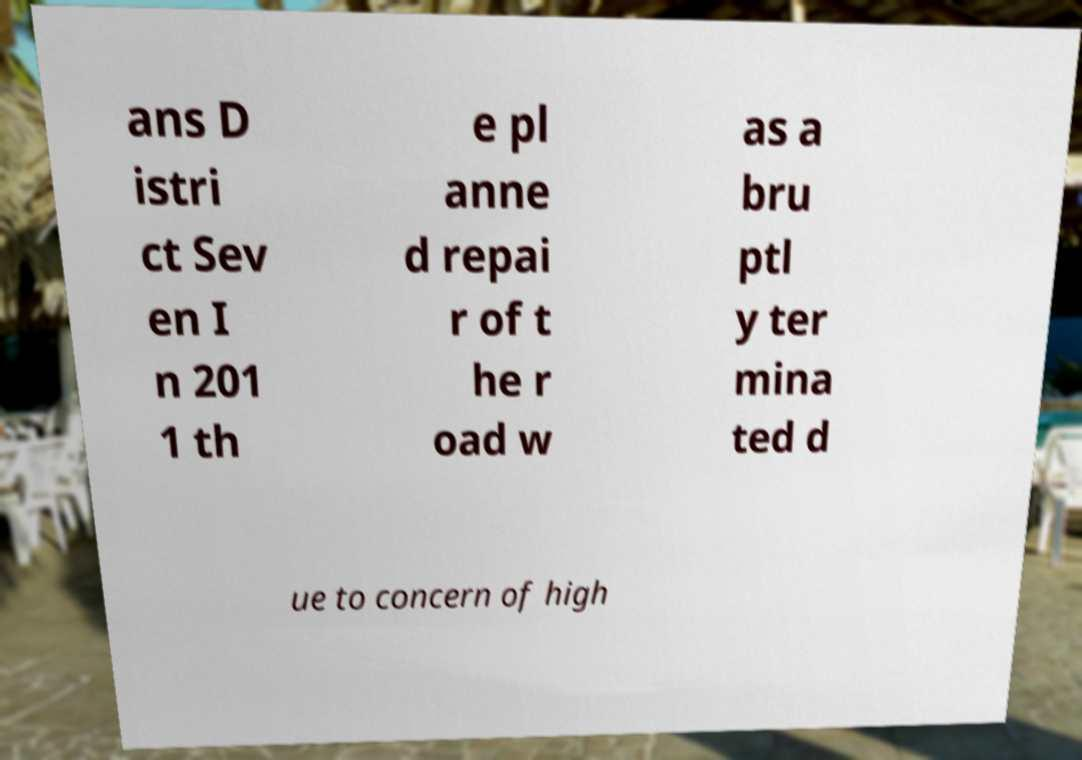For documentation purposes, I need the text within this image transcribed. Could you provide that? ans D istri ct Sev en I n 201 1 th e pl anne d repai r of t he r oad w as a bru ptl y ter mina ted d ue to concern of high 